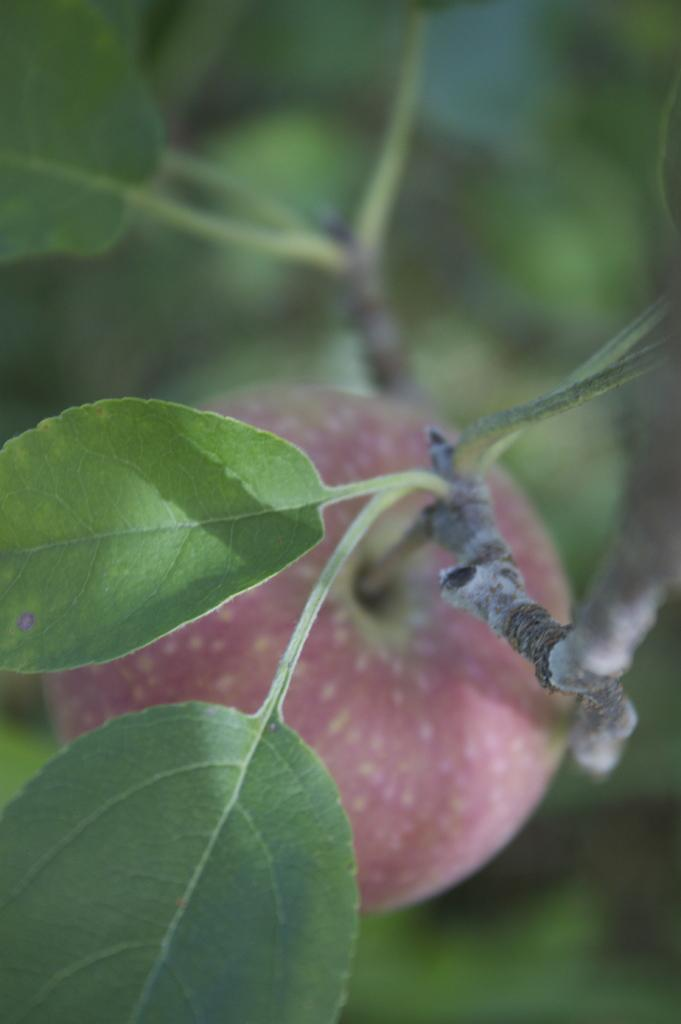What type of plant material is present in the image? There are leaves in the image. What type of fruit is present in the image? There is an apple in the image. What type of bird can be seen perched on the branch in the image? There is no branch or bird present in the image; it only features leaves and an apple. 